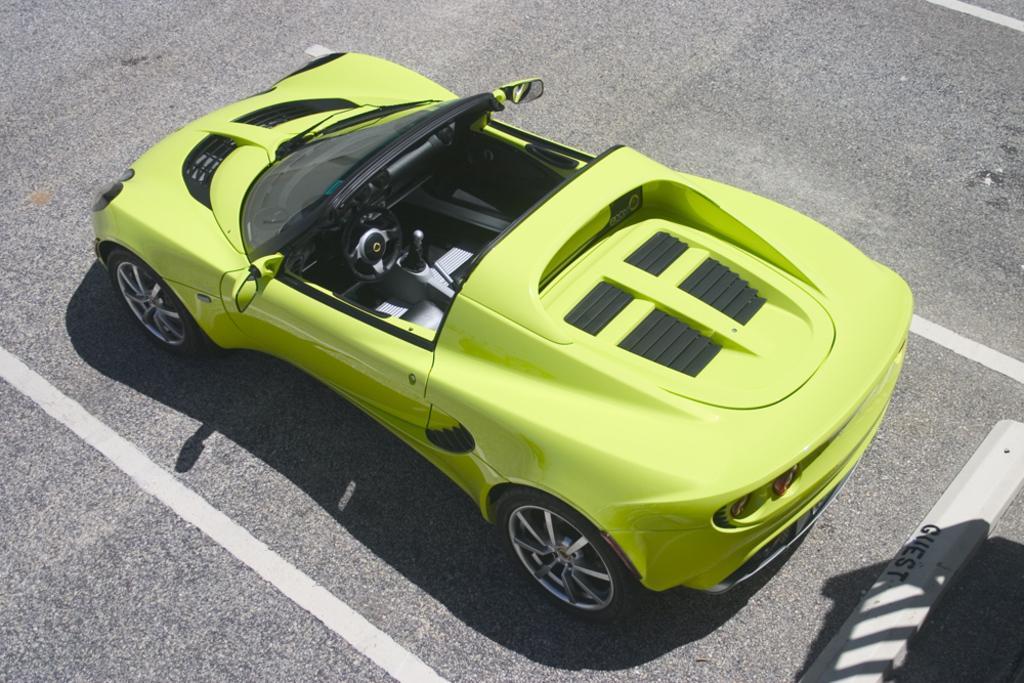Can you describe this image briefly? In the middle I can see a car on the road. This image is taken may be during a day. 